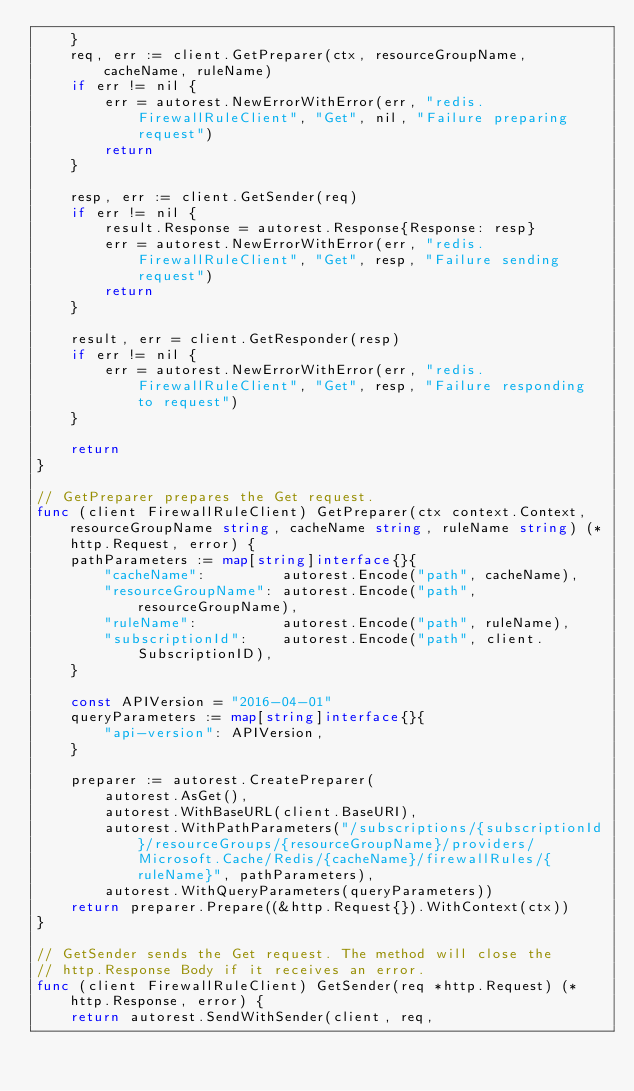Convert code to text. <code><loc_0><loc_0><loc_500><loc_500><_Go_>	}
	req, err := client.GetPreparer(ctx, resourceGroupName, cacheName, ruleName)
	if err != nil {
		err = autorest.NewErrorWithError(err, "redis.FirewallRuleClient", "Get", nil, "Failure preparing request")
		return
	}

	resp, err := client.GetSender(req)
	if err != nil {
		result.Response = autorest.Response{Response: resp}
		err = autorest.NewErrorWithError(err, "redis.FirewallRuleClient", "Get", resp, "Failure sending request")
		return
	}

	result, err = client.GetResponder(resp)
	if err != nil {
		err = autorest.NewErrorWithError(err, "redis.FirewallRuleClient", "Get", resp, "Failure responding to request")
	}

	return
}

// GetPreparer prepares the Get request.
func (client FirewallRuleClient) GetPreparer(ctx context.Context, resourceGroupName string, cacheName string, ruleName string) (*http.Request, error) {
	pathParameters := map[string]interface{}{
		"cacheName":         autorest.Encode("path", cacheName),
		"resourceGroupName": autorest.Encode("path", resourceGroupName),
		"ruleName":          autorest.Encode("path", ruleName),
		"subscriptionId":    autorest.Encode("path", client.SubscriptionID),
	}

	const APIVersion = "2016-04-01"
	queryParameters := map[string]interface{}{
		"api-version": APIVersion,
	}

	preparer := autorest.CreatePreparer(
		autorest.AsGet(),
		autorest.WithBaseURL(client.BaseURI),
		autorest.WithPathParameters("/subscriptions/{subscriptionId}/resourceGroups/{resourceGroupName}/providers/Microsoft.Cache/Redis/{cacheName}/firewallRules/{ruleName}", pathParameters),
		autorest.WithQueryParameters(queryParameters))
	return preparer.Prepare((&http.Request{}).WithContext(ctx))
}

// GetSender sends the Get request. The method will close the
// http.Response Body if it receives an error.
func (client FirewallRuleClient) GetSender(req *http.Request) (*http.Response, error) {
	return autorest.SendWithSender(client, req,</code> 